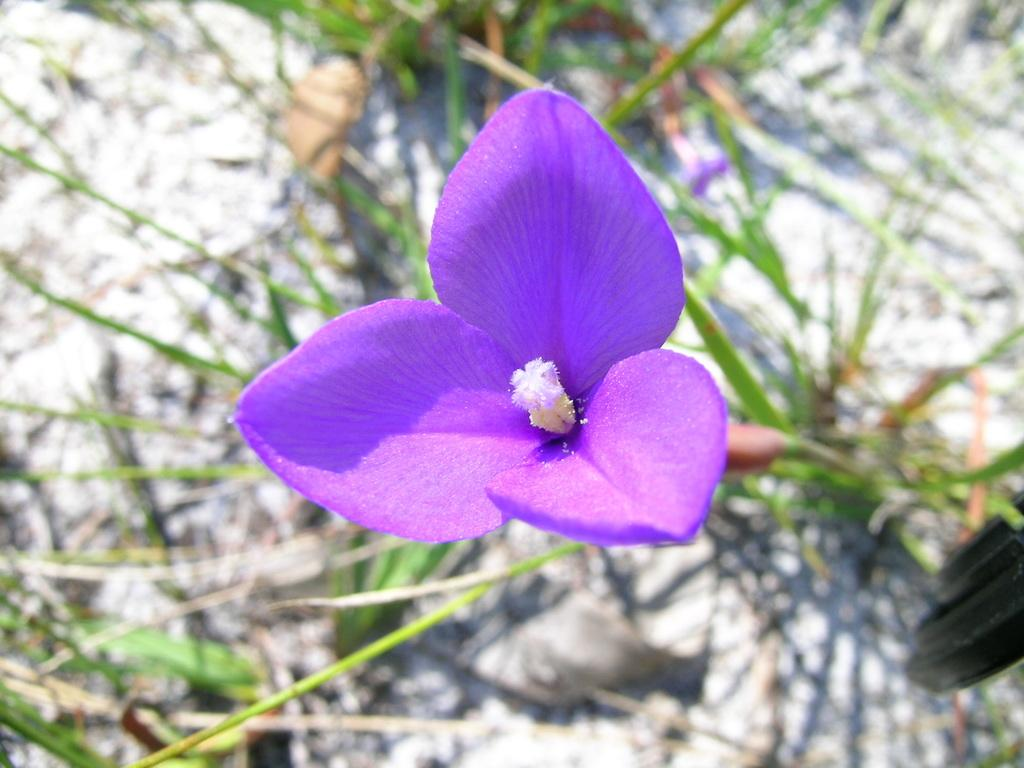What is the main subject of the image? The main subject of the image is a flower. Can you describe the color of the flower? The flower is in violet color. What type of surface is visible in the image? There is grass on the surface in the image. What type of soda is being served during the morning protest in the image? There is no soda or protest present in the image; it features a violet-colored flower and grass. 